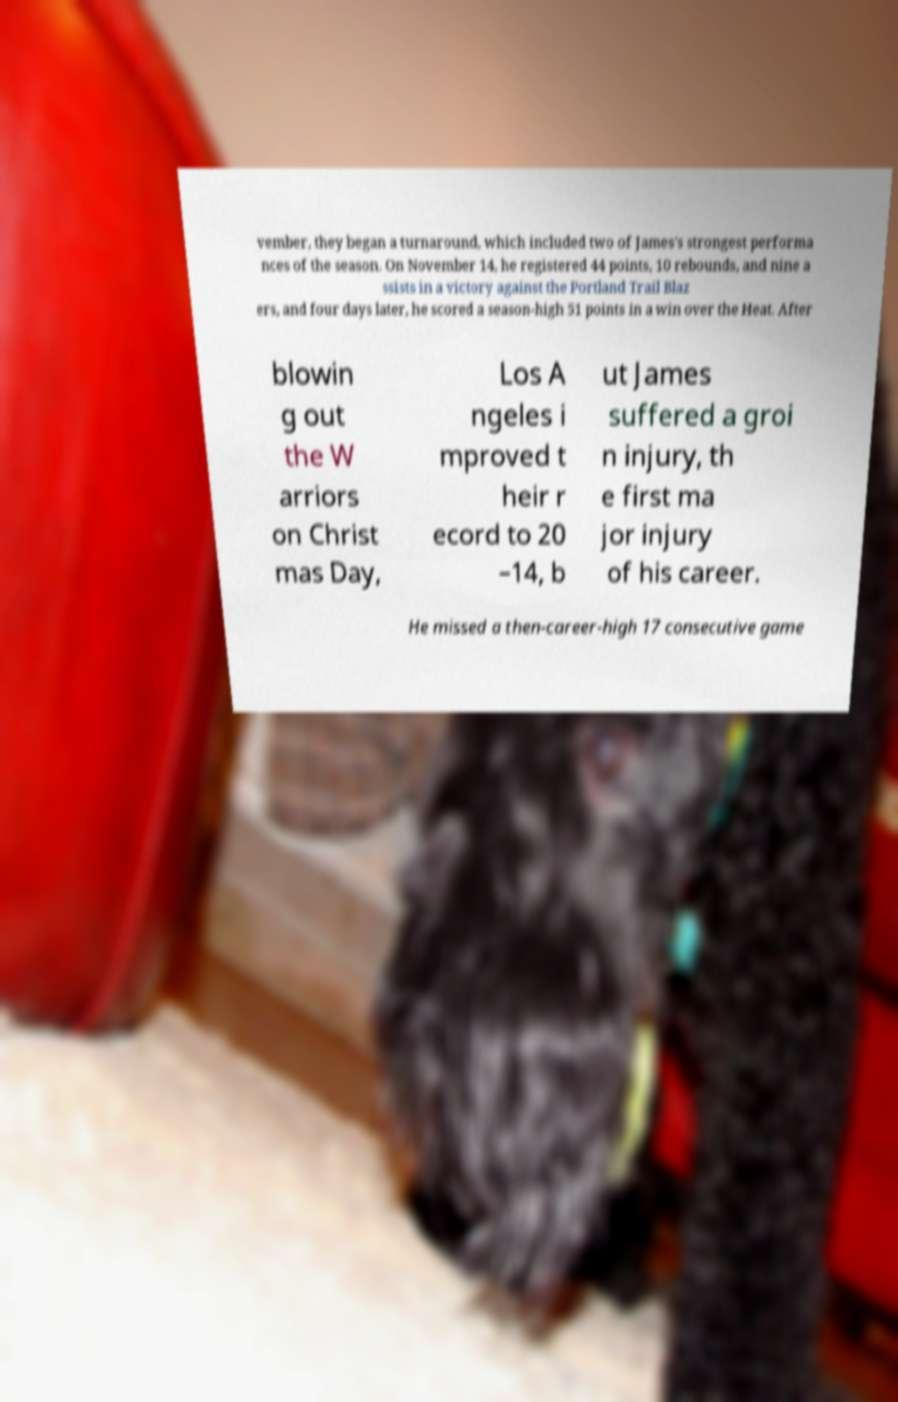There's text embedded in this image that I need extracted. Can you transcribe it verbatim? vember, they began a turnaround, which included two of James's strongest performa nces of the season. On November 14, he registered 44 points, 10 rebounds, and nine a ssists in a victory against the Portland Trail Blaz ers, and four days later, he scored a season-high 51 points in a win over the Heat. After blowin g out the W arriors on Christ mas Day, Los A ngeles i mproved t heir r ecord to 20 –14, b ut James suffered a groi n injury, th e first ma jor injury of his career. He missed a then-career-high 17 consecutive game 